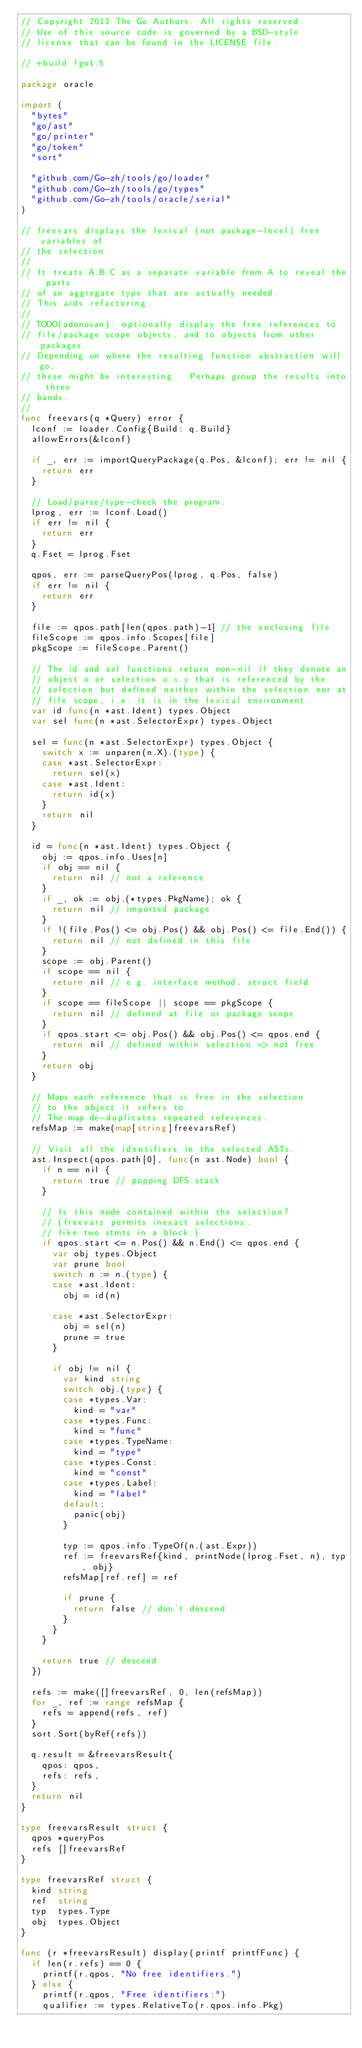<code> <loc_0><loc_0><loc_500><loc_500><_Go_>// Copyright 2013 The Go Authors. All rights reserved.
// Use of this source code is governed by a BSD-style
// license that can be found in the LICENSE file.

// +build !go1.5

package oracle

import (
	"bytes"
	"go/ast"
	"go/printer"
	"go/token"
	"sort"

	"github.com/Go-zh/tools/go/loader"
	"github.com/Go-zh/tools/go/types"
	"github.com/Go-zh/tools/oracle/serial"
)

// freevars displays the lexical (not package-level) free variables of
// the selection.
//
// It treats A.B.C as a separate variable from A to reveal the parts
// of an aggregate type that are actually needed.
// This aids refactoring.
//
// TODO(adonovan): optionally display the free references to
// file/package scope objects, and to objects from other packages.
// Depending on where the resulting function abstraction will go,
// these might be interesting.  Perhaps group the results into three
// bands.
//
func freevars(q *Query) error {
	lconf := loader.Config{Build: q.Build}
	allowErrors(&lconf)

	if _, err := importQueryPackage(q.Pos, &lconf); err != nil {
		return err
	}

	// Load/parse/type-check the program.
	lprog, err := lconf.Load()
	if err != nil {
		return err
	}
	q.Fset = lprog.Fset

	qpos, err := parseQueryPos(lprog, q.Pos, false)
	if err != nil {
		return err
	}

	file := qpos.path[len(qpos.path)-1] // the enclosing file
	fileScope := qpos.info.Scopes[file]
	pkgScope := fileScope.Parent()

	// The id and sel functions return non-nil if they denote an
	// object o or selection o.x.y that is referenced by the
	// selection but defined neither within the selection nor at
	// file scope, i.e. it is in the lexical environment.
	var id func(n *ast.Ident) types.Object
	var sel func(n *ast.SelectorExpr) types.Object

	sel = func(n *ast.SelectorExpr) types.Object {
		switch x := unparen(n.X).(type) {
		case *ast.SelectorExpr:
			return sel(x)
		case *ast.Ident:
			return id(x)
		}
		return nil
	}

	id = func(n *ast.Ident) types.Object {
		obj := qpos.info.Uses[n]
		if obj == nil {
			return nil // not a reference
		}
		if _, ok := obj.(*types.PkgName); ok {
			return nil // imported package
		}
		if !(file.Pos() <= obj.Pos() && obj.Pos() <= file.End()) {
			return nil // not defined in this file
		}
		scope := obj.Parent()
		if scope == nil {
			return nil // e.g. interface method, struct field
		}
		if scope == fileScope || scope == pkgScope {
			return nil // defined at file or package scope
		}
		if qpos.start <= obj.Pos() && obj.Pos() <= qpos.end {
			return nil // defined within selection => not free
		}
		return obj
	}

	// Maps each reference that is free in the selection
	// to the object it refers to.
	// The map de-duplicates repeated references.
	refsMap := make(map[string]freevarsRef)

	// Visit all the identifiers in the selected ASTs.
	ast.Inspect(qpos.path[0], func(n ast.Node) bool {
		if n == nil {
			return true // popping DFS stack
		}

		// Is this node contained within the selection?
		// (freevars permits inexact selections,
		// like two stmts in a block.)
		if qpos.start <= n.Pos() && n.End() <= qpos.end {
			var obj types.Object
			var prune bool
			switch n := n.(type) {
			case *ast.Ident:
				obj = id(n)

			case *ast.SelectorExpr:
				obj = sel(n)
				prune = true
			}

			if obj != nil {
				var kind string
				switch obj.(type) {
				case *types.Var:
					kind = "var"
				case *types.Func:
					kind = "func"
				case *types.TypeName:
					kind = "type"
				case *types.Const:
					kind = "const"
				case *types.Label:
					kind = "label"
				default:
					panic(obj)
				}

				typ := qpos.info.TypeOf(n.(ast.Expr))
				ref := freevarsRef{kind, printNode(lprog.Fset, n), typ, obj}
				refsMap[ref.ref] = ref

				if prune {
					return false // don't descend
				}
			}
		}

		return true // descend
	})

	refs := make([]freevarsRef, 0, len(refsMap))
	for _, ref := range refsMap {
		refs = append(refs, ref)
	}
	sort.Sort(byRef(refs))

	q.result = &freevarsResult{
		qpos: qpos,
		refs: refs,
	}
	return nil
}

type freevarsResult struct {
	qpos *queryPos
	refs []freevarsRef
}

type freevarsRef struct {
	kind string
	ref  string
	typ  types.Type
	obj  types.Object
}

func (r *freevarsResult) display(printf printfFunc) {
	if len(r.refs) == 0 {
		printf(r.qpos, "No free identifiers.")
	} else {
		printf(r.qpos, "Free identifiers:")
		qualifier := types.RelativeTo(r.qpos.info.Pkg)</code> 